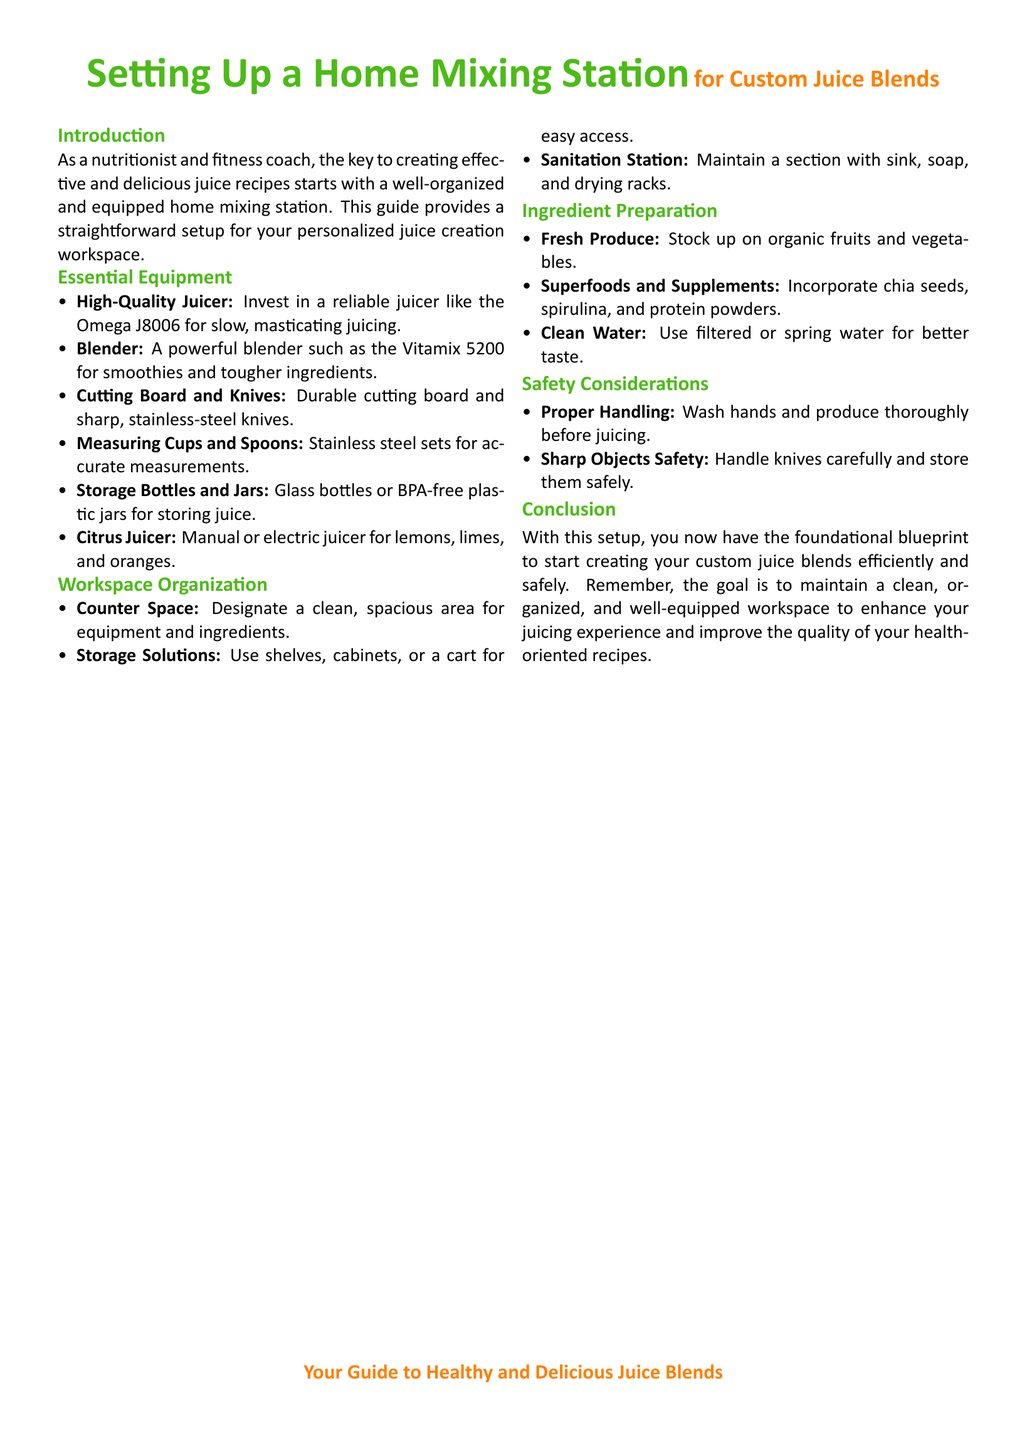What is the first piece of essential equipment listed? The first piece of essential equipment in the document is a high-quality juicer.
Answer: High-Quality Juicer What type of juicer is recommended? The document recommends a specific type of juicer, the Omega J8006, for masticating juicing.
Answer: Omega J8006 What is an important consideration for workspace organization? The document emphasizes designating a clean, spacious area for equipment and ingredients.
Answer: Counter Space Which superfood is mentioned in the ingredient preparation section? The document lists specific superfoods, among which chia seeds are included.
Answer: Chia seeds How many essential equipment items are listed? The document lists six items under essential equipment.
Answer: 6 What should you use for better taste in smoothies? The document advises to use filtered or spring water for better taste.
Answer: Clean Water What is the purpose of a sanitation station? The sanitation station is meant for maintaining a clean area with a sink, soap, and drying racks.
Answer: Maintain cleanliness What is the document's main focus? The focus of the document is to provide guidance on setting up a home mixing station for juicing.
Answer: Custom Juice Blends What type of products should you stock up on for juicing? The document advises stocking up on organic fruits and vegetables for juicing.
Answer: Organic fruits and vegetables 